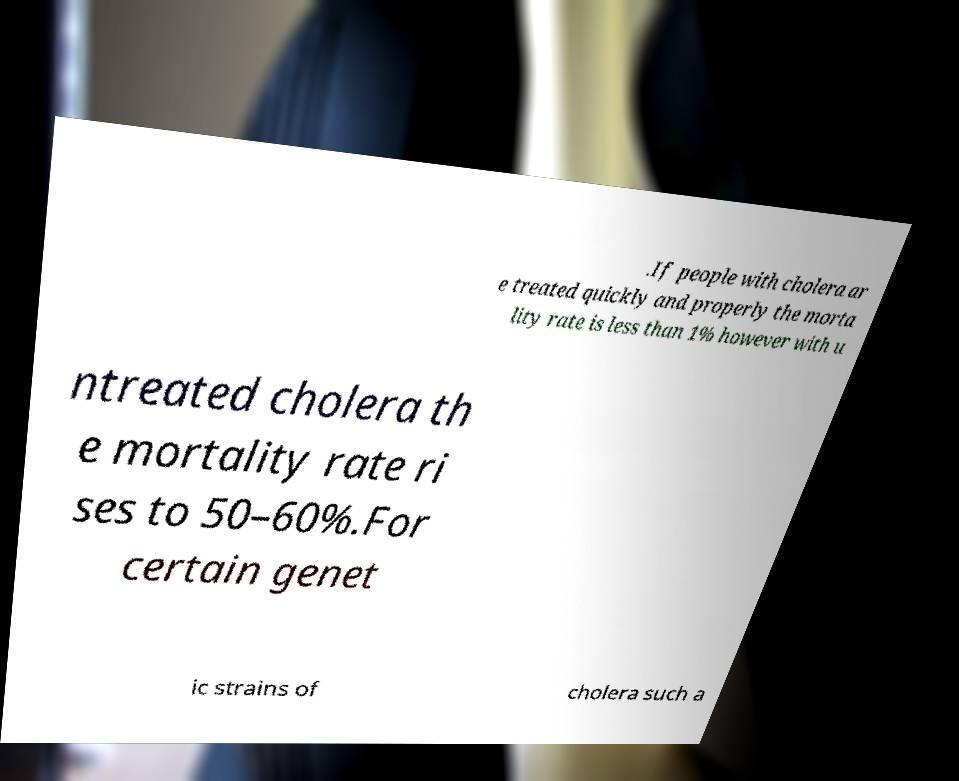There's text embedded in this image that I need extracted. Can you transcribe it verbatim? .If people with cholera ar e treated quickly and properly the morta lity rate is less than 1% however with u ntreated cholera th e mortality rate ri ses to 50–60%.For certain genet ic strains of cholera such a 